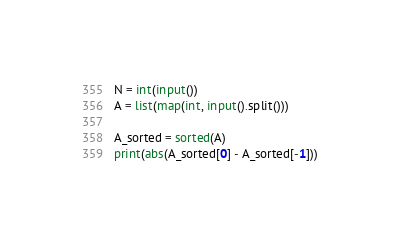<code> <loc_0><loc_0><loc_500><loc_500><_Python_>N = int(input())
A = list(map(int, input().split()))

A_sorted = sorted(A)
print(abs(A_sorted[0] - A_sorted[-1]))</code> 